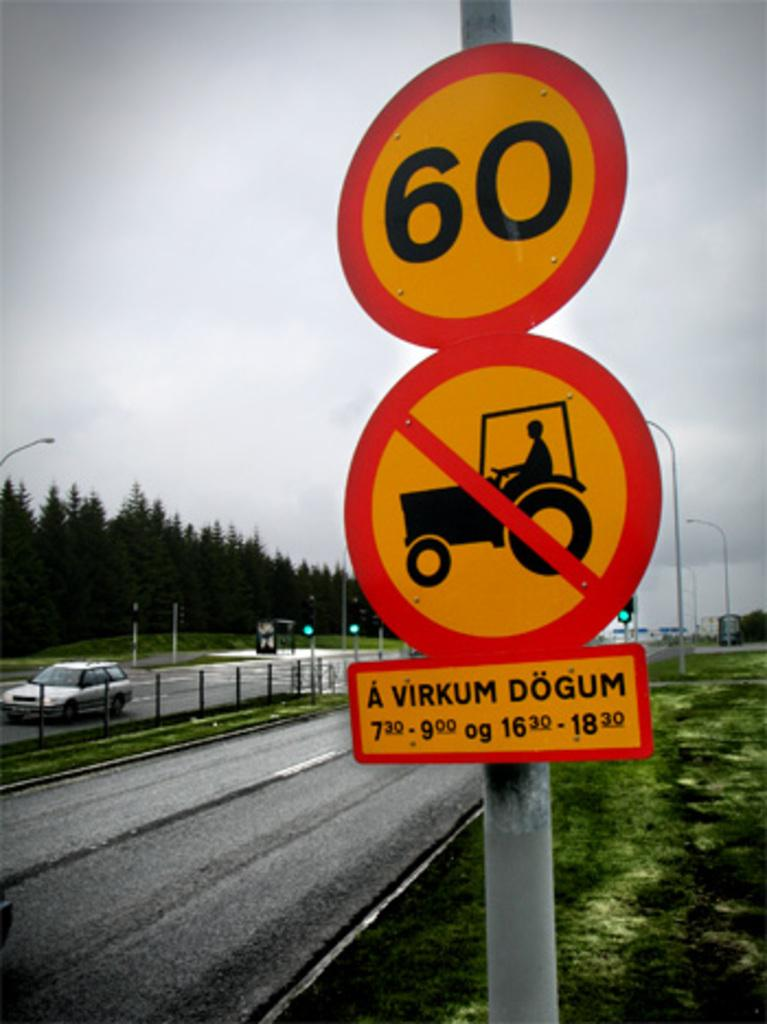Provide a one-sentence caption for the provided image. Two street signs prohibiting tractors and setting the maximum speed limit to 60. 